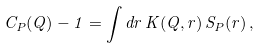Convert formula to latex. <formula><loc_0><loc_0><loc_500><loc_500>C _ { P } ( { Q } ) - 1 = \int d { r } \, K ( { Q } , { r } ) \, S _ { P } ( { r } ) \, ,</formula> 